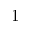Convert formula to latex. <formula><loc_0><loc_0><loc_500><loc_500>1</formula> 